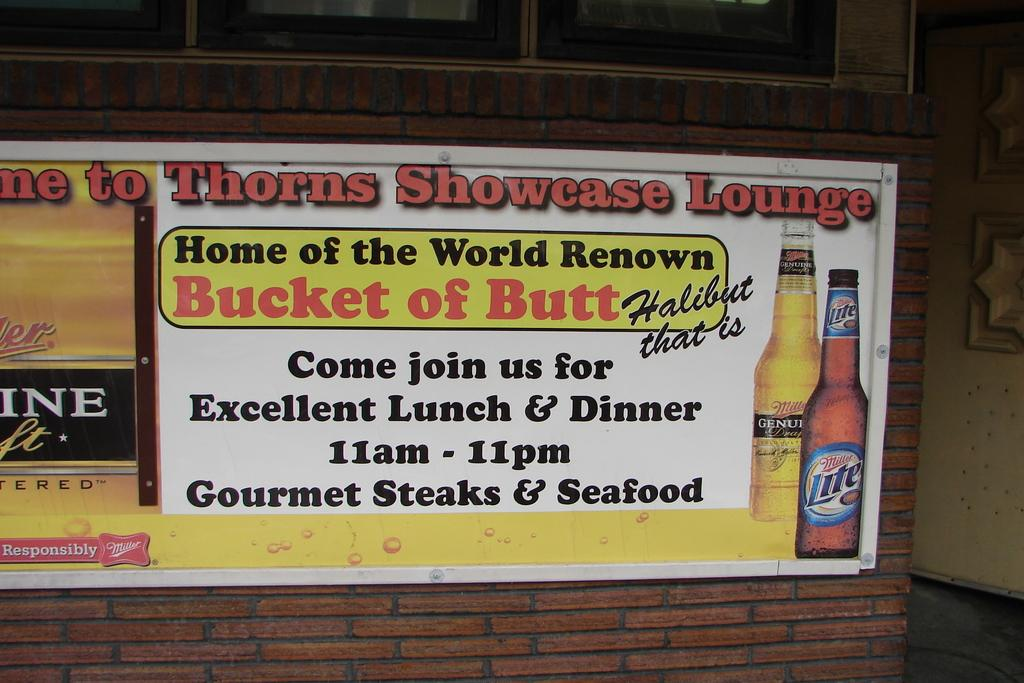<image>
Write a terse but informative summary of the picture. An advertisement for Thorns Showcase Lounge to join them for lunch and dinner. 